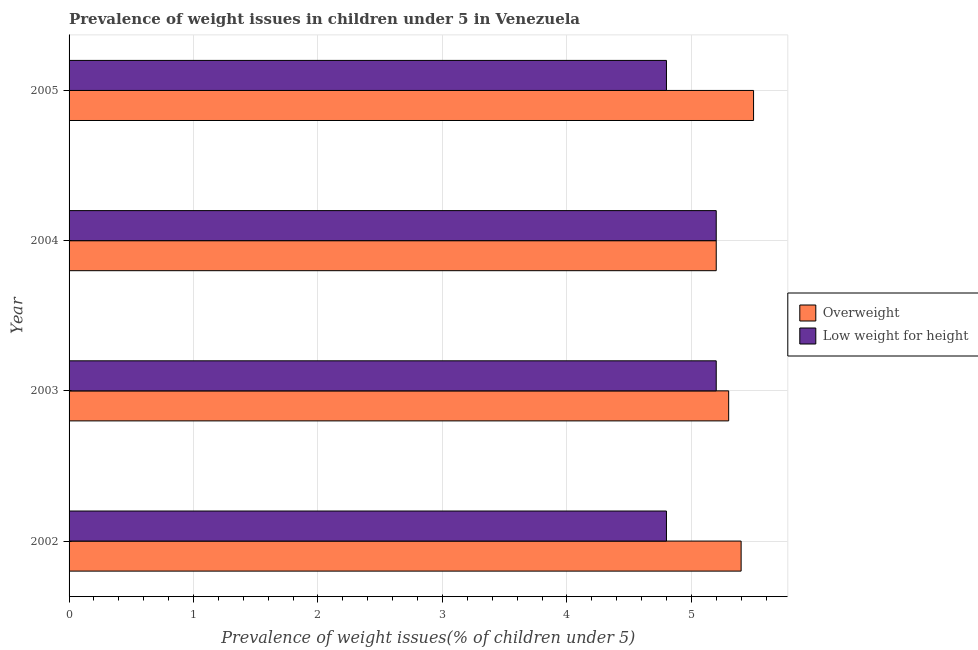How many groups of bars are there?
Offer a terse response. 4. Are the number of bars per tick equal to the number of legend labels?
Give a very brief answer. Yes. Are the number of bars on each tick of the Y-axis equal?
Your answer should be compact. Yes. What is the label of the 2nd group of bars from the top?
Ensure brevity in your answer.  2004. In how many cases, is the number of bars for a given year not equal to the number of legend labels?
Provide a short and direct response. 0. What is the percentage of underweight children in 2002?
Ensure brevity in your answer.  4.8. Across all years, what is the maximum percentage of overweight children?
Offer a terse response. 5.5. Across all years, what is the minimum percentage of underweight children?
Your answer should be compact. 4.8. In which year was the percentage of overweight children maximum?
Your answer should be very brief. 2005. In which year was the percentage of underweight children minimum?
Ensure brevity in your answer.  2002. What is the difference between the percentage of underweight children in 2004 and the percentage of overweight children in 2005?
Your response must be concise. -0.3. What is the average percentage of overweight children per year?
Your response must be concise. 5.35. In how many years, is the percentage of underweight children greater than 3.6 %?
Give a very brief answer. 4. Is the percentage of underweight children in 2003 less than that in 2005?
Provide a short and direct response. No. Is the difference between the percentage of overweight children in 2003 and 2005 greater than the difference between the percentage of underweight children in 2003 and 2005?
Provide a short and direct response. No. What is the difference between the highest and the second highest percentage of underweight children?
Your answer should be compact. 0. What is the difference between the highest and the lowest percentage of overweight children?
Give a very brief answer. 0.3. What does the 2nd bar from the top in 2005 represents?
Make the answer very short. Overweight. What does the 1st bar from the bottom in 2002 represents?
Your response must be concise. Overweight. Are all the bars in the graph horizontal?
Provide a short and direct response. Yes. Does the graph contain any zero values?
Offer a very short reply. No. Does the graph contain grids?
Ensure brevity in your answer.  Yes. How are the legend labels stacked?
Keep it short and to the point. Vertical. What is the title of the graph?
Ensure brevity in your answer.  Prevalence of weight issues in children under 5 in Venezuela. What is the label or title of the X-axis?
Your response must be concise. Prevalence of weight issues(% of children under 5). What is the label or title of the Y-axis?
Your response must be concise. Year. What is the Prevalence of weight issues(% of children under 5) in Overweight in 2002?
Make the answer very short. 5.4. What is the Prevalence of weight issues(% of children under 5) in Low weight for height in 2002?
Give a very brief answer. 4.8. What is the Prevalence of weight issues(% of children under 5) in Overweight in 2003?
Offer a terse response. 5.3. What is the Prevalence of weight issues(% of children under 5) in Low weight for height in 2003?
Provide a succinct answer. 5.2. What is the Prevalence of weight issues(% of children under 5) in Overweight in 2004?
Offer a terse response. 5.2. What is the Prevalence of weight issues(% of children under 5) of Low weight for height in 2004?
Your answer should be compact. 5.2. What is the Prevalence of weight issues(% of children under 5) in Overweight in 2005?
Offer a terse response. 5.5. What is the Prevalence of weight issues(% of children under 5) of Low weight for height in 2005?
Keep it short and to the point. 4.8. Across all years, what is the maximum Prevalence of weight issues(% of children under 5) of Low weight for height?
Your answer should be very brief. 5.2. Across all years, what is the minimum Prevalence of weight issues(% of children under 5) in Overweight?
Provide a succinct answer. 5.2. Across all years, what is the minimum Prevalence of weight issues(% of children under 5) of Low weight for height?
Keep it short and to the point. 4.8. What is the total Prevalence of weight issues(% of children under 5) in Overweight in the graph?
Your answer should be very brief. 21.4. What is the total Prevalence of weight issues(% of children under 5) of Low weight for height in the graph?
Offer a very short reply. 20. What is the difference between the Prevalence of weight issues(% of children under 5) of Low weight for height in 2002 and that in 2003?
Your answer should be very brief. -0.4. What is the difference between the Prevalence of weight issues(% of children under 5) of Overweight in 2002 and that in 2004?
Offer a very short reply. 0.2. What is the difference between the Prevalence of weight issues(% of children under 5) in Low weight for height in 2002 and that in 2004?
Keep it short and to the point. -0.4. What is the difference between the Prevalence of weight issues(% of children under 5) in Overweight in 2002 and that in 2005?
Your answer should be compact. -0.1. What is the difference between the Prevalence of weight issues(% of children under 5) of Low weight for height in 2004 and that in 2005?
Your answer should be compact. 0.4. What is the difference between the Prevalence of weight issues(% of children under 5) of Overweight in 2002 and the Prevalence of weight issues(% of children under 5) of Low weight for height in 2005?
Provide a short and direct response. 0.6. What is the difference between the Prevalence of weight issues(% of children under 5) in Overweight in 2003 and the Prevalence of weight issues(% of children under 5) in Low weight for height in 2004?
Keep it short and to the point. 0.1. What is the difference between the Prevalence of weight issues(% of children under 5) of Overweight in 2003 and the Prevalence of weight issues(% of children under 5) of Low weight for height in 2005?
Provide a short and direct response. 0.5. What is the difference between the Prevalence of weight issues(% of children under 5) of Overweight in 2004 and the Prevalence of weight issues(% of children under 5) of Low weight for height in 2005?
Offer a very short reply. 0.4. What is the average Prevalence of weight issues(% of children under 5) in Overweight per year?
Provide a short and direct response. 5.35. What is the average Prevalence of weight issues(% of children under 5) of Low weight for height per year?
Make the answer very short. 5. In the year 2002, what is the difference between the Prevalence of weight issues(% of children under 5) of Overweight and Prevalence of weight issues(% of children under 5) of Low weight for height?
Your answer should be compact. 0.6. In the year 2004, what is the difference between the Prevalence of weight issues(% of children under 5) in Overweight and Prevalence of weight issues(% of children under 5) in Low weight for height?
Your answer should be compact. 0. What is the ratio of the Prevalence of weight issues(% of children under 5) of Overweight in 2002 to that in 2003?
Provide a succinct answer. 1.02. What is the ratio of the Prevalence of weight issues(% of children under 5) in Low weight for height in 2002 to that in 2003?
Keep it short and to the point. 0.92. What is the ratio of the Prevalence of weight issues(% of children under 5) in Overweight in 2002 to that in 2004?
Your answer should be very brief. 1.04. What is the ratio of the Prevalence of weight issues(% of children under 5) in Low weight for height in 2002 to that in 2004?
Provide a succinct answer. 0.92. What is the ratio of the Prevalence of weight issues(% of children under 5) of Overweight in 2002 to that in 2005?
Your answer should be very brief. 0.98. What is the ratio of the Prevalence of weight issues(% of children under 5) in Overweight in 2003 to that in 2004?
Provide a short and direct response. 1.02. What is the ratio of the Prevalence of weight issues(% of children under 5) of Overweight in 2003 to that in 2005?
Offer a very short reply. 0.96. What is the ratio of the Prevalence of weight issues(% of children under 5) of Overweight in 2004 to that in 2005?
Your response must be concise. 0.95. What is the difference between the highest and the second highest Prevalence of weight issues(% of children under 5) in Overweight?
Make the answer very short. 0.1. What is the difference between the highest and the second highest Prevalence of weight issues(% of children under 5) in Low weight for height?
Keep it short and to the point. 0. What is the difference between the highest and the lowest Prevalence of weight issues(% of children under 5) of Overweight?
Your answer should be compact. 0.3. What is the difference between the highest and the lowest Prevalence of weight issues(% of children under 5) in Low weight for height?
Ensure brevity in your answer.  0.4. 